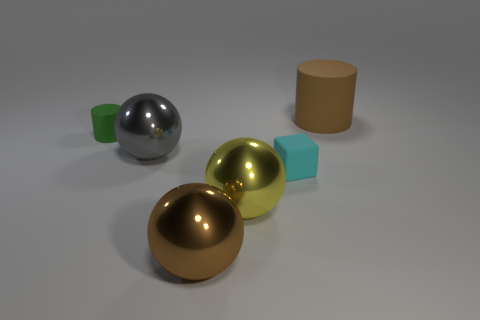Is the number of things in front of the small cylinder the same as the number of big gray metal objects?
Provide a succinct answer. No. Is there anything else that has the same material as the cyan thing?
Make the answer very short. Yes. How many large objects are either balls or matte blocks?
Provide a short and direct response. 3. Do the cylinder in front of the brown rubber object and the brown cylinder have the same material?
Offer a terse response. Yes. The gray ball that is in front of the small thing that is behind the cyan matte cube is made of what material?
Ensure brevity in your answer.  Metal. How many other small rubber things are the same shape as the gray thing?
Give a very brief answer. 0. There is a matte cylinder to the left of the small matte thing that is on the right side of the big brown thing that is to the left of the big cylinder; what size is it?
Your answer should be compact. Small. What number of gray objects are small matte cylinders or shiny things?
Your answer should be compact. 1. Do the brown object that is behind the big gray ball and the small cyan thing have the same shape?
Provide a short and direct response. No. Are there more big gray spheres in front of the gray ball than gray spheres?
Your response must be concise. No. 